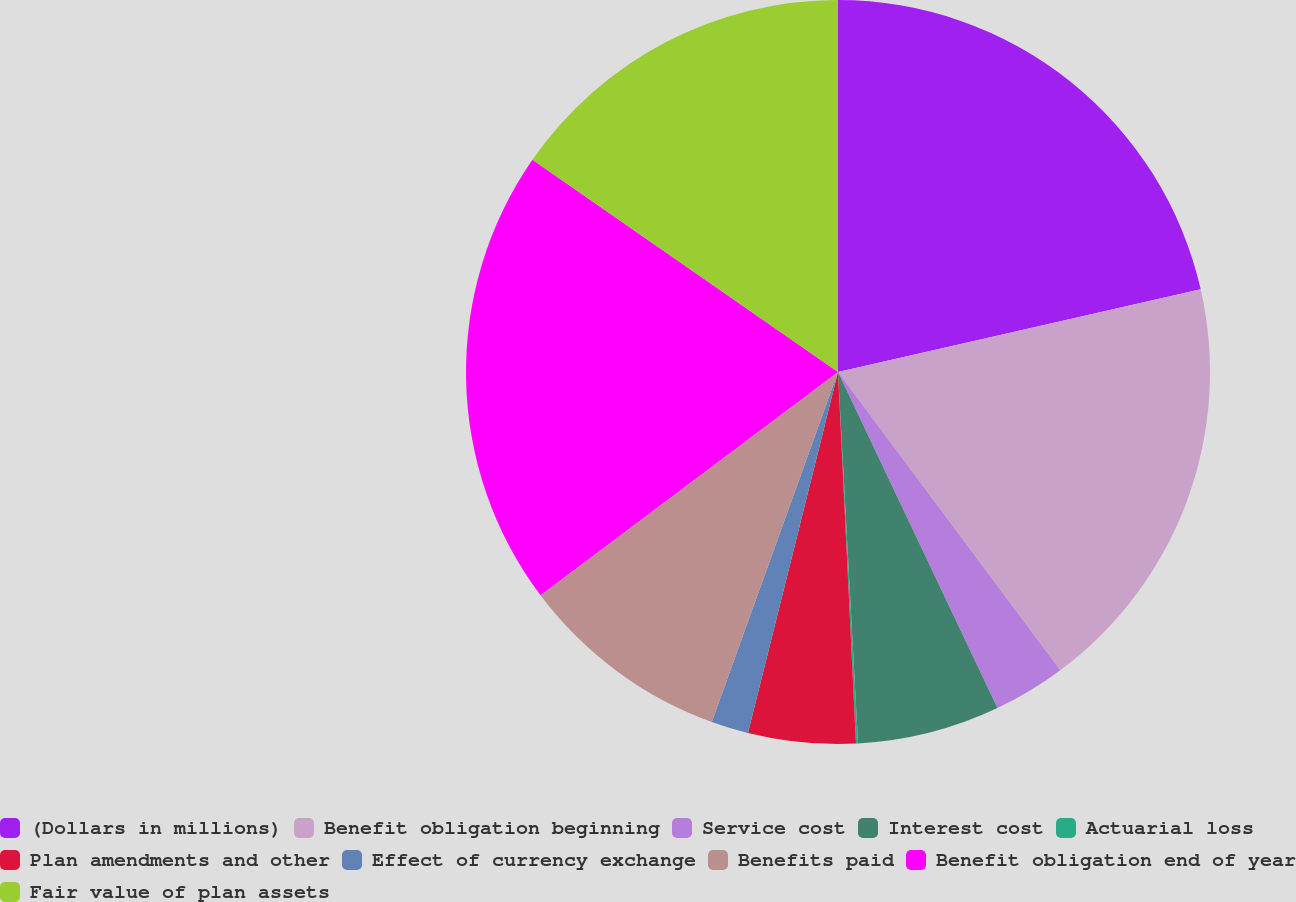Convert chart to OTSL. <chart><loc_0><loc_0><loc_500><loc_500><pie_chart><fcel>(Dollars in millions)<fcel>Benefit obligation beginning<fcel>Service cost<fcel>Interest cost<fcel>Actuarial loss<fcel>Plan amendments and other<fcel>Effect of currency exchange<fcel>Benefits paid<fcel>Benefit obligation end of year<fcel>Fair value of plan assets<nl><fcel>21.43%<fcel>18.38%<fcel>3.14%<fcel>6.19%<fcel>0.09%<fcel>4.66%<fcel>1.62%<fcel>9.24%<fcel>19.91%<fcel>15.34%<nl></chart> 